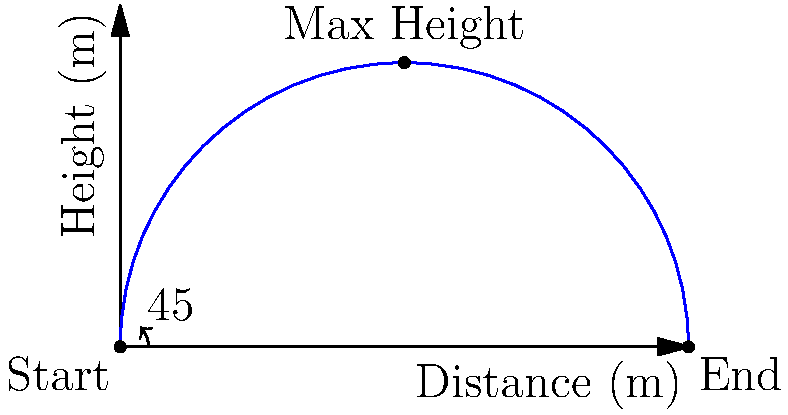You're demonstrating a medicine ball throw to your gym buddy. You launch the ball at a 45-degree angle with an initial velocity of 10 m/s. Assuming no air resistance, what is the maximum height reached by the medicine ball? Let's break this down step-by-step:

1) The trajectory of a projectile launched at an angle follows a parabolic path.

2) For a 45-degree launch angle, the vertical and horizontal components of the initial velocity are equal:
   $v_x = v_y = 10 \cdot \cos(45°) = 10 \cdot \sin(45°) = 10 \cdot \frac{\sqrt{2}}{2} \approx 7.07$ m/s

3) The maximum height is reached when the vertical velocity becomes zero. We can use the equation:
   $v_y^2 = v_{0y}^2 - 2gy$

   Where:
   $v_y = 0$ (at the highest point)
   $v_{0y} = 7.07$ m/s (initial vertical velocity)
   $g = 9.8$ m/s² (acceleration due to gravity)
   $y = $ maximum height (what we're solving for)

4) Plugging in the values:
   $0^2 = (7.07)^2 - 2(9.8)y$

5) Solving for y:
   $y = \frac{(7.07)^2}{2(9.8)} \approx 2.55$ m

Therefore, the maximum height reached by the medicine ball is approximately 2.55 meters.
Answer: 2.55 m 